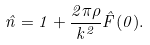<formula> <loc_0><loc_0><loc_500><loc_500>\hat { n } = 1 + \frac { 2 \pi \rho } { k ^ { 2 } } \hat { F } ( 0 ) .</formula> 